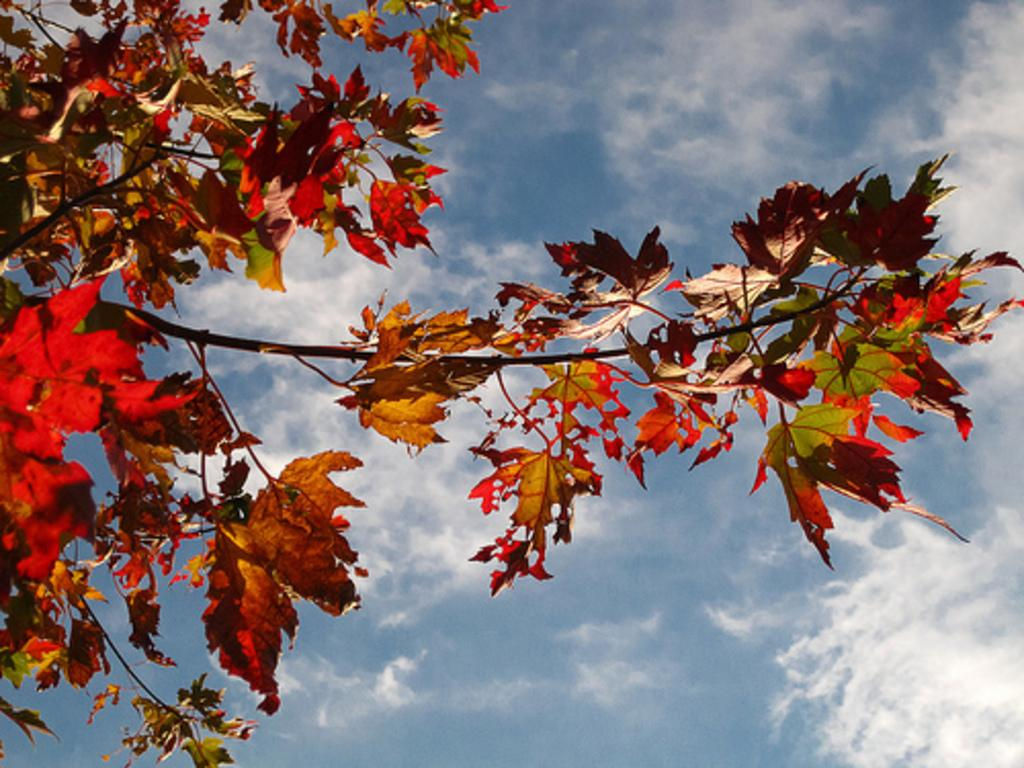What type of vegetation can be seen in the image? There are branches with leaves in the image. What is visible in the background of the image? There is sky visible in the image. What can be seen in the sky? Clouds are present in the sky. What type of base is supporting the donkey in the image? There is no donkey present in the image. Can you point out the map in the image? There is no map present in the image. 